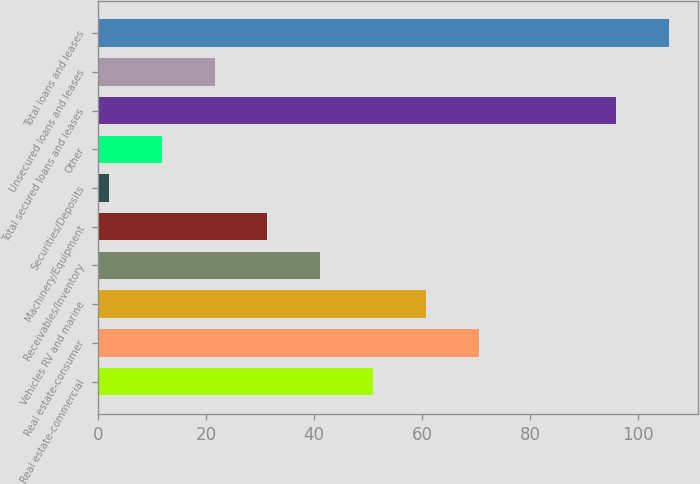<chart> <loc_0><loc_0><loc_500><loc_500><bar_chart><fcel>Real estate-commercial<fcel>Real estate-consumer<fcel>Vehicles RV and marine<fcel>Receivables/Inventory<fcel>Machinery/Equipment<fcel>Securities/Deposits<fcel>Other<fcel>Total secured loans and leases<fcel>Unsecured loans and leases<fcel>Total loans and leases<nl><fcel>51<fcel>70.6<fcel>60.8<fcel>41.2<fcel>31.4<fcel>2<fcel>11.8<fcel>96<fcel>21.6<fcel>105.8<nl></chart> 